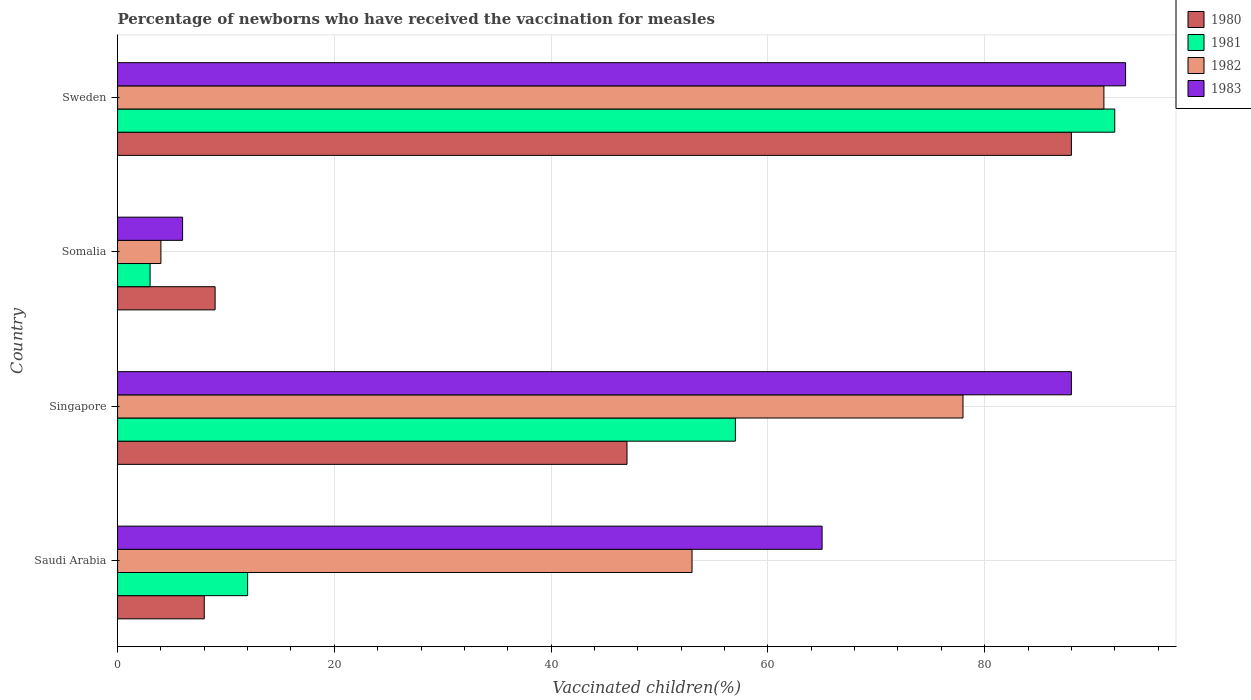How many groups of bars are there?
Ensure brevity in your answer.  4. Are the number of bars on each tick of the Y-axis equal?
Provide a short and direct response. Yes. How many bars are there on the 1st tick from the top?
Offer a terse response. 4. How many bars are there on the 4th tick from the bottom?
Keep it short and to the point. 4. What is the label of the 3rd group of bars from the top?
Provide a short and direct response. Singapore. Across all countries, what is the maximum percentage of vaccinated children in 1981?
Provide a succinct answer. 92. Across all countries, what is the minimum percentage of vaccinated children in 1980?
Give a very brief answer. 8. In which country was the percentage of vaccinated children in 1980 maximum?
Your response must be concise. Sweden. In which country was the percentage of vaccinated children in 1983 minimum?
Offer a very short reply. Somalia. What is the total percentage of vaccinated children in 1982 in the graph?
Your answer should be very brief. 226. What is the difference between the percentage of vaccinated children in 1982 in Singapore and that in Sweden?
Make the answer very short. -13. What is the difference between the percentage of vaccinated children in 1983 in Somalia and the percentage of vaccinated children in 1980 in Sweden?
Keep it short and to the point. -82. What is the average percentage of vaccinated children in 1982 per country?
Provide a short and direct response. 56.5. What is the difference between the percentage of vaccinated children in 1981 and percentage of vaccinated children in 1980 in Saudi Arabia?
Your response must be concise. 4. In how many countries, is the percentage of vaccinated children in 1980 greater than 52 %?
Your response must be concise. 1. What is the ratio of the percentage of vaccinated children in 1983 in Saudi Arabia to that in Singapore?
Ensure brevity in your answer.  0.74. Is the difference between the percentage of vaccinated children in 1981 in Somalia and Sweden greater than the difference between the percentage of vaccinated children in 1980 in Somalia and Sweden?
Give a very brief answer. No. What is the difference between the highest and the lowest percentage of vaccinated children in 1983?
Provide a short and direct response. 87. Is the sum of the percentage of vaccinated children in 1982 in Saudi Arabia and Singapore greater than the maximum percentage of vaccinated children in 1980 across all countries?
Your answer should be compact. Yes. Is it the case that in every country, the sum of the percentage of vaccinated children in 1980 and percentage of vaccinated children in 1982 is greater than the percentage of vaccinated children in 1983?
Ensure brevity in your answer.  No. Are the values on the major ticks of X-axis written in scientific E-notation?
Your answer should be compact. No. Where does the legend appear in the graph?
Provide a short and direct response. Top right. How are the legend labels stacked?
Give a very brief answer. Vertical. What is the title of the graph?
Offer a very short reply. Percentage of newborns who have received the vaccination for measles. Does "1975" appear as one of the legend labels in the graph?
Provide a short and direct response. No. What is the label or title of the X-axis?
Your answer should be compact. Vaccinated children(%). What is the Vaccinated children(%) of 1982 in Saudi Arabia?
Ensure brevity in your answer.  53. What is the Vaccinated children(%) of 1983 in Saudi Arabia?
Ensure brevity in your answer.  65. What is the Vaccinated children(%) in 1981 in Singapore?
Your answer should be very brief. 57. What is the Vaccinated children(%) of 1982 in Singapore?
Offer a terse response. 78. What is the Vaccinated children(%) in 1981 in Somalia?
Your response must be concise. 3. What is the Vaccinated children(%) of 1981 in Sweden?
Make the answer very short. 92. What is the Vaccinated children(%) of 1982 in Sweden?
Provide a short and direct response. 91. What is the Vaccinated children(%) of 1983 in Sweden?
Keep it short and to the point. 93. Across all countries, what is the maximum Vaccinated children(%) of 1981?
Your answer should be very brief. 92. Across all countries, what is the maximum Vaccinated children(%) of 1982?
Offer a very short reply. 91. Across all countries, what is the maximum Vaccinated children(%) of 1983?
Offer a very short reply. 93. Across all countries, what is the minimum Vaccinated children(%) in 1980?
Make the answer very short. 8. Across all countries, what is the minimum Vaccinated children(%) of 1981?
Offer a terse response. 3. Across all countries, what is the minimum Vaccinated children(%) of 1982?
Ensure brevity in your answer.  4. What is the total Vaccinated children(%) of 1980 in the graph?
Provide a short and direct response. 152. What is the total Vaccinated children(%) of 1981 in the graph?
Your answer should be compact. 164. What is the total Vaccinated children(%) in 1982 in the graph?
Keep it short and to the point. 226. What is the total Vaccinated children(%) in 1983 in the graph?
Provide a short and direct response. 252. What is the difference between the Vaccinated children(%) in 1980 in Saudi Arabia and that in Singapore?
Your response must be concise. -39. What is the difference between the Vaccinated children(%) of 1981 in Saudi Arabia and that in Singapore?
Keep it short and to the point. -45. What is the difference between the Vaccinated children(%) in 1983 in Saudi Arabia and that in Singapore?
Offer a terse response. -23. What is the difference between the Vaccinated children(%) in 1980 in Saudi Arabia and that in Somalia?
Give a very brief answer. -1. What is the difference between the Vaccinated children(%) in 1981 in Saudi Arabia and that in Somalia?
Give a very brief answer. 9. What is the difference between the Vaccinated children(%) in 1982 in Saudi Arabia and that in Somalia?
Provide a short and direct response. 49. What is the difference between the Vaccinated children(%) in 1983 in Saudi Arabia and that in Somalia?
Your answer should be very brief. 59. What is the difference between the Vaccinated children(%) of 1980 in Saudi Arabia and that in Sweden?
Ensure brevity in your answer.  -80. What is the difference between the Vaccinated children(%) in 1981 in Saudi Arabia and that in Sweden?
Provide a short and direct response. -80. What is the difference between the Vaccinated children(%) of 1982 in Saudi Arabia and that in Sweden?
Give a very brief answer. -38. What is the difference between the Vaccinated children(%) of 1983 in Saudi Arabia and that in Sweden?
Offer a very short reply. -28. What is the difference between the Vaccinated children(%) in 1982 in Singapore and that in Somalia?
Your answer should be very brief. 74. What is the difference between the Vaccinated children(%) of 1980 in Singapore and that in Sweden?
Keep it short and to the point. -41. What is the difference between the Vaccinated children(%) of 1981 in Singapore and that in Sweden?
Ensure brevity in your answer.  -35. What is the difference between the Vaccinated children(%) of 1980 in Somalia and that in Sweden?
Your answer should be very brief. -79. What is the difference between the Vaccinated children(%) in 1981 in Somalia and that in Sweden?
Offer a terse response. -89. What is the difference between the Vaccinated children(%) in 1982 in Somalia and that in Sweden?
Your response must be concise. -87. What is the difference between the Vaccinated children(%) of 1983 in Somalia and that in Sweden?
Offer a very short reply. -87. What is the difference between the Vaccinated children(%) in 1980 in Saudi Arabia and the Vaccinated children(%) in 1981 in Singapore?
Provide a succinct answer. -49. What is the difference between the Vaccinated children(%) in 1980 in Saudi Arabia and the Vaccinated children(%) in 1982 in Singapore?
Ensure brevity in your answer.  -70. What is the difference between the Vaccinated children(%) in 1980 in Saudi Arabia and the Vaccinated children(%) in 1983 in Singapore?
Your answer should be very brief. -80. What is the difference between the Vaccinated children(%) of 1981 in Saudi Arabia and the Vaccinated children(%) of 1982 in Singapore?
Keep it short and to the point. -66. What is the difference between the Vaccinated children(%) of 1981 in Saudi Arabia and the Vaccinated children(%) of 1983 in Singapore?
Keep it short and to the point. -76. What is the difference between the Vaccinated children(%) of 1982 in Saudi Arabia and the Vaccinated children(%) of 1983 in Singapore?
Give a very brief answer. -35. What is the difference between the Vaccinated children(%) in 1980 in Saudi Arabia and the Vaccinated children(%) in 1981 in Somalia?
Ensure brevity in your answer.  5. What is the difference between the Vaccinated children(%) of 1980 in Saudi Arabia and the Vaccinated children(%) of 1983 in Somalia?
Your response must be concise. 2. What is the difference between the Vaccinated children(%) of 1981 in Saudi Arabia and the Vaccinated children(%) of 1983 in Somalia?
Offer a very short reply. 6. What is the difference between the Vaccinated children(%) in 1980 in Saudi Arabia and the Vaccinated children(%) in 1981 in Sweden?
Keep it short and to the point. -84. What is the difference between the Vaccinated children(%) of 1980 in Saudi Arabia and the Vaccinated children(%) of 1982 in Sweden?
Ensure brevity in your answer.  -83. What is the difference between the Vaccinated children(%) in 1980 in Saudi Arabia and the Vaccinated children(%) in 1983 in Sweden?
Offer a terse response. -85. What is the difference between the Vaccinated children(%) in 1981 in Saudi Arabia and the Vaccinated children(%) in 1982 in Sweden?
Your answer should be very brief. -79. What is the difference between the Vaccinated children(%) in 1981 in Saudi Arabia and the Vaccinated children(%) in 1983 in Sweden?
Make the answer very short. -81. What is the difference between the Vaccinated children(%) of 1980 in Singapore and the Vaccinated children(%) of 1981 in Somalia?
Offer a very short reply. 44. What is the difference between the Vaccinated children(%) in 1981 in Singapore and the Vaccinated children(%) in 1982 in Somalia?
Provide a short and direct response. 53. What is the difference between the Vaccinated children(%) in 1980 in Singapore and the Vaccinated children(%) in 1981 in Sweden?
Make the answer very short. -45. What is the difference between the Vaccinated children(%) of 1980 in Singapore and the Vaccinated children(%) of 1982 in Sweden?
Your answer should be compact. -44. What is the difference between the Vaccinated children(%) in 1980 in Singapore and the Vaccinated children(%) in 1983 in Sweden?
Ensure brevity in your answer.  -46. What is the difference between the Vaccinated children(%) in 1981 in Singapore and the Vaccinated children(%) in 1982 in Sweden?
Make the answer very short. -34. What is the difference between the Vaccinated children(%) of 1981 in Singapore and the Vaccinated children(%) of 1983 in Sweden?
Make the answer very short. -36. What is the difference between the Vaccinated children(%) of 1982 in Singapore and the Vaccinated children(%) of 1983 in Sweden?
Your response must be concise. -15. What is the difference between the Vaccinated children(%) of 1980 in Somalia and the Vaccinated children(%) of 1981 in Sweden?
Keep it short and to the point. -83. What is the difference between the Vaccinated children(%) in 1980 in Somalia and the Vaccinated children(%) in 1982 in Sweden?
Provide a short and direct response. -82. What is the difference between the Vaccinated children(%) in 1980 in Somalia and the Vaccinated children(%) in 1983 in Sweden?
Your answer should be compact. -84. What is the difference between the Vaccinated children(%) in 1981 in Somalia and the Vaccinated children(%) in 1982 in Sweden?
Give a very brief answer. -88. What is the difference between the Vaccinated children(%) in 1981 in Somalia and the Vaccinated children(%) in 1983 in Sweden?
Provide a succinct answer. -90. What is the difference between the Vaccinated children(%) of 1982 in Somalia and the Vaccinated children(%) of 1983 in Sweden?
Make the answer very short. -89. What is the average Vaccinated children(%) of 1982 per country?
Your answer should be very brief. 56.5. What is the difference between the Vaccinated children(%) of 1980 and Vaccinated children(%) of 1982 in Saudi Arabia?
Ensure brevity in your answer.  -45. What is the difference between the Vaccinated children(%) of 1980 and Vaccinated children(%) of 1983 in Saudi Arabia?
Provide a short and direct response. -57. What is the difference between the Vaccinated children(%) in 1981 and Vaccinated children(%) in 1982 in Saudi Arabia?
Offer a very short reply. -41. What is the difference between the Vaccinated children(%) of 1981 and Vaccinated children(%) of 1983 in Saudi Arabia?
Make the answer very short. -53. What is the difference between the Vaccinated children(%) of 1982 and Vaccinated children(%) of 1983 in Saudi Arabia?
Your answer should be very brief. -12. What is the difference between the Vaccinated children(%) of 1980 and Vaccinated children(%) of 1982 in Singapore?
Ensure brevity in your answer.  -31. What is the difference between the Vaccinated children(%) in 1980 and Vaccinated children(%) in 1983 in Singapore?
Provide a succinct answer. -41. What is the difference between the Vaccinated children(%) in 1981 and Vaccinated children(%) in 1982 in Singapore?
Give a very brief answer. -21. What is the difference between the Vaccinated children(%) in 1981 and Vaccinated children(%) in 1983 in Singapore?
Offer a terse response. -31. What is the difference between the Vaccinated children(%) of 1980 and Vaccinated children(%) of 1981 in Somalia?
Give a very brief answer. 6. What is the difference between the Vaccinated children(%) of 1981 and Vaccinated children(%) of 1982 in Somalia?
Provide a succinct answer. -1. What is the difference between the Vaccinated children(%) in 1981 and Vaccinated children(%) in 1983 in Somalia?
Provide a short and direct response. -3. What is the difference between the Vaccinated children(%) in 1982 and Vaccinated children(%) in 1983 in Somalia?
Give a very brief answer. -2. What is the difference between the Vaccinated children(%) in 1980 and Vaccinated children(%) in 1983 in Sweden?
Provide a short and direct response. -5. What is the difference between the Vaccinated children(%) of 1981 and Vaccinated children(%) of 1982 in Sweden?
Offer a very short reply. 1. What is the difference between the Vaccinated children(%) in 1982 and Vaccinated children(%) in 1983 in Sweden?
Give a very brief answer. -2. What is the ratio of the Vaccinated children(%) in 1980 in Saudi Arabia to that in Singapore?
Offer a very short reply. 0.17. What is the ratio of the Vaccinated children(%) of 1981 in Saudi Arabia to that in Singapore?
Your answer should be very brief. 0.21. What is the ratio of the Vaccinated children(%) of 1982 in Saudi Arabia to that in Singapore?
Your answer should be compact. 0.68. What is the ratio of the Vaccinated children(%) of 1983 in Saudi Arabia to that in Singapore?
Provide a short and direct response. 0.74. What is the ratio of the Vaccinated children(%) in 1980 in Saudi Arabia to that in Somalia?
Provide a succinct answer. 0.89. What is the ratio of the Vaccinated children(%) of 1982 in Saudi Arabia to that in Somalia?
Offer a very short reply. 13.25. What is the ratio of the Vaccinated children(%) of 1983 in Saudi Arabia to that in Somalia?
Your response must be concise. 10.83. What is the ratio of the Vaccinated children(%) of 1980 in Saudi Arabia to that in Sweden?
Offer a very short reply. 0.09. What is the ratio of the Vaccinated children(%) in 1981 in Saudi Arabia to that in Sweden?
Your answer should be compact. 0.13. What is the ratio of the Vaccinated children(%) of 1982 in Saudi Arabia to that in Sweden?
Provide a succinct answer. 0.58. What is the ratio of the Vaccinated children(%) in 1983 in Saudi Arabia to that in Sweden?
Provide a short and direct response. 0.7. What is the ratio of the Vaccinated children(%) of 1980 in Singapore to that in Somalia?
Make the answer very short. 5.22. What is the ratio of the Vaccinated children(%) of 1981 in Singapore to that in Somalia?
Your response must be concise. 19. What is the ratio of the Vaccinated children(%) in 1982 in Singapore to that in Somalia?
Offer a terse response. 19.5. What is the ratio of the Vaccinated children(%) in 1983 in Singapore to that in Somalia?
Your answer should be compact. 14.67. What is the ratio of the Vaccinated children(%) in 1980 in Singapore to that in Sweden?
Your answer should be compact. 0.53. What is the ratio of the Vaccinated children(%) of 1981 in Singapore to that in Sweden?
Provide a succinct answer. 0.62. What is the ratio of the Vaccinated children(%) in 1982 in Singapore to that in Sweden?
Offer a very short reply. 0.86. What is the ratio of the Vaccinated children(%) in 1983 in Singapore to that in Sweden?
Your answer should be compact. 0.95. What is the ratio of the Vaccinated children(%) of 1980 in Somalia to that in Sweden?
Give a very brief answer. 0.1. What is the ratio of the Vaccinated children(%) in 1981 in Somalia to that in Sweden?
Provide a short and direct response. 0.03. What is the ratio of the Vaccinated children(%) of 1982 in Somalia to that in Sweden?
Your answer should be very brief. 0.04. What is the ratio of the Vaccinated children(%) of 1983 in Somalia to that in Sweden?
Your response must be concise. 0.06. What is the difference between the highest and the second highest Vaccinated children(%) in 1980?
Make the answer very short. 41. What is the difference between the highest and the second highest Vaccinated children(%) of 1981?
Provide a short and direct response. 35. What is the difference between the highest and the second highest Vaccinated children(%) in 1983?
Offer a very short reply. 5. What is the difference between the highest and the lowest Vaccinated children(%) in 1981?
Make the answer very short. 89. What is the difference between the highest and the lowest Vaccinated children(%) in 1982?
Ensure brevity in your answer.  87. 